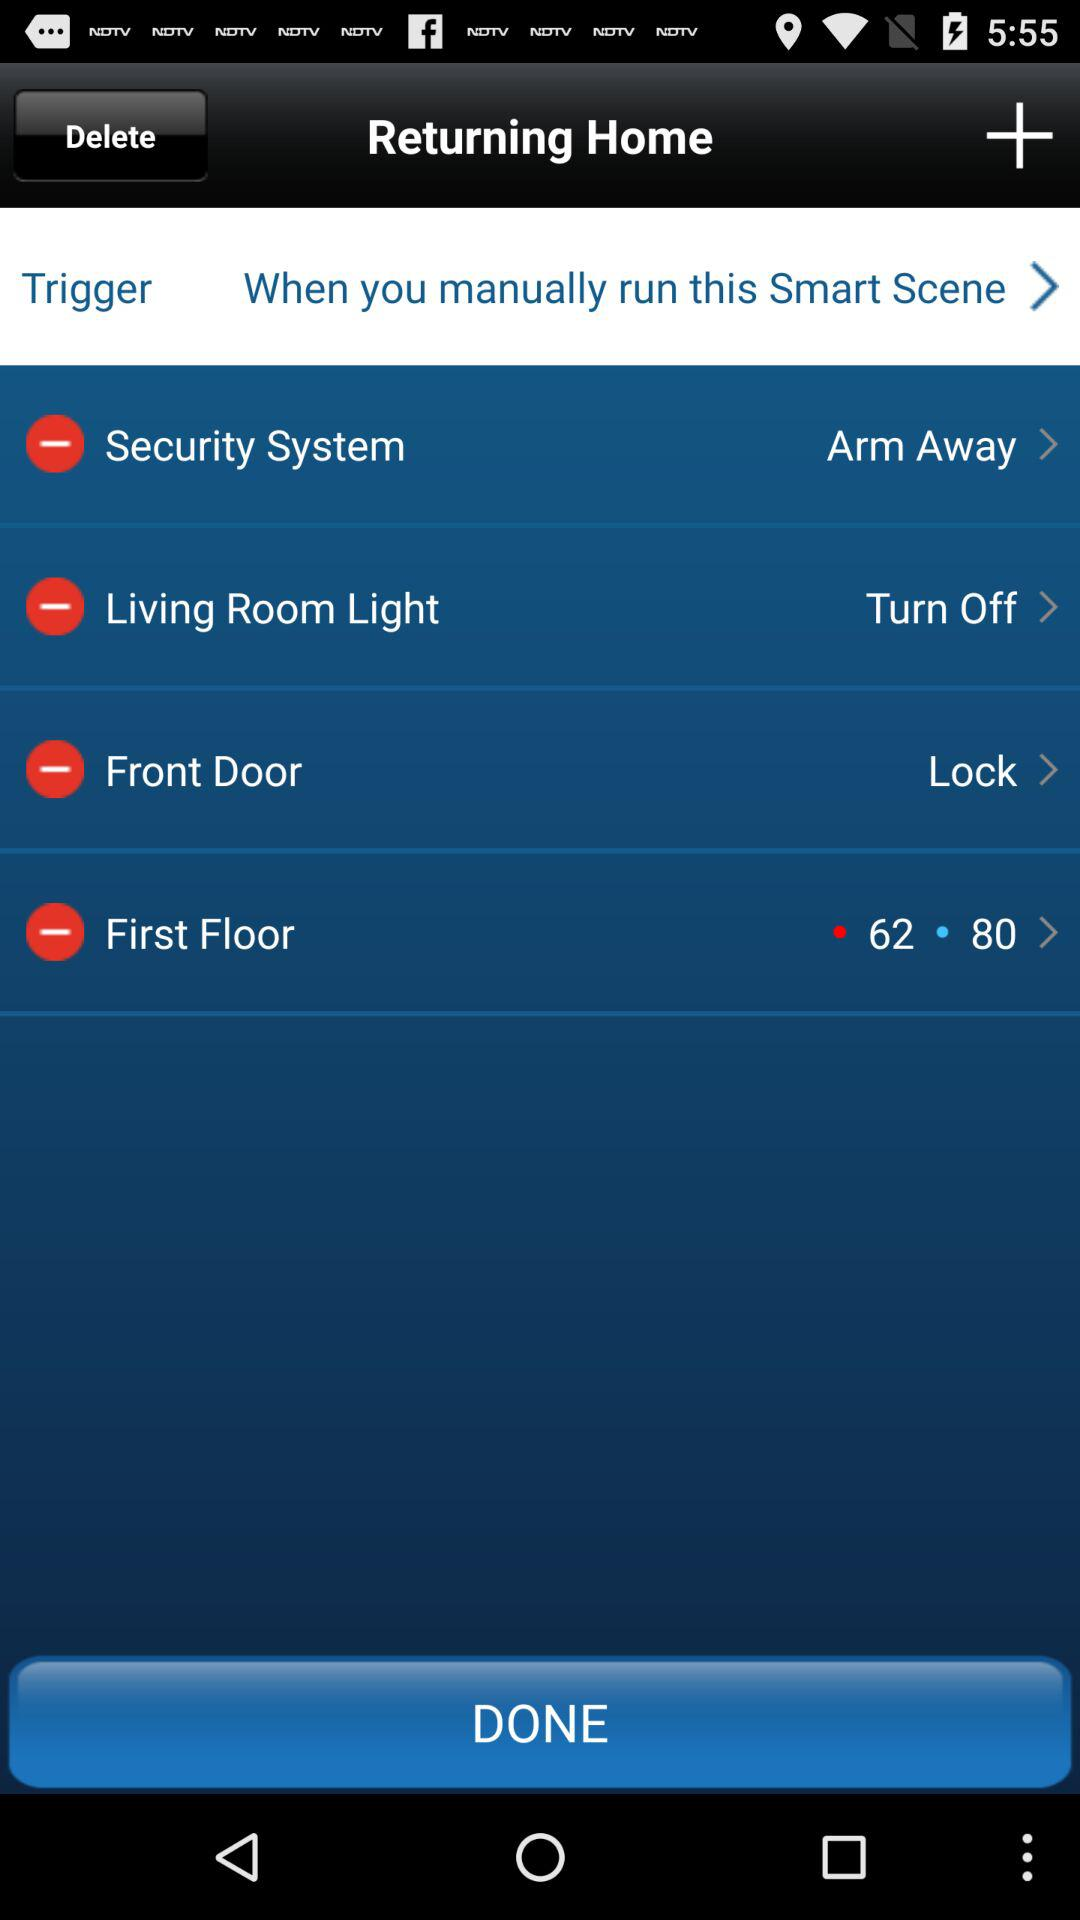How many actions are in the Returning Home smart scene?
Answer the question using a single word or phrase. 4 